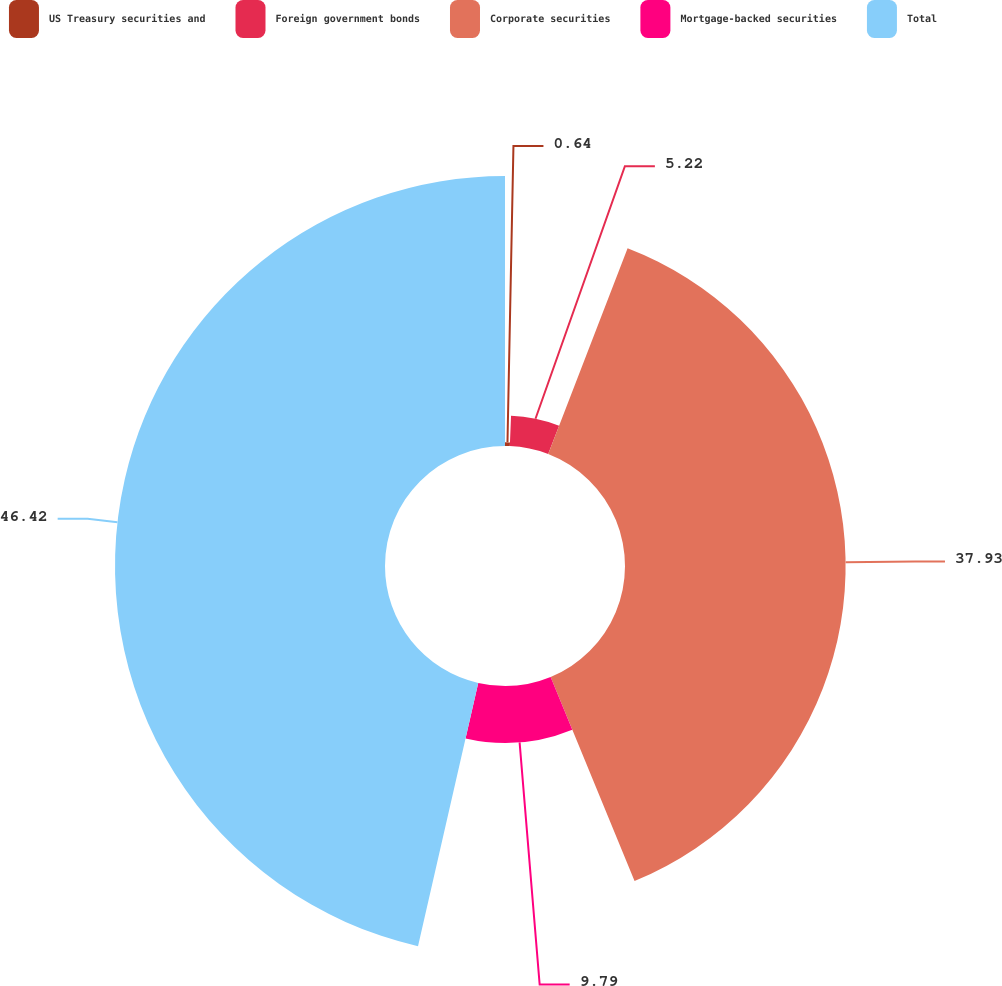Convert chart. <chart><loc_0><loc_0><loc_500><loc_500><pie_chart><fcel>US Treasury securities and<fcel>Foreign government bonds<fcel>Corporate securities<fcel>Mortgage-backed securities<fcel>Total<nl><fcel>0.64%<fcel>5.22%<fcel>37.93%<fcel>9.79%<fcel>46.42%<nl></chart> 